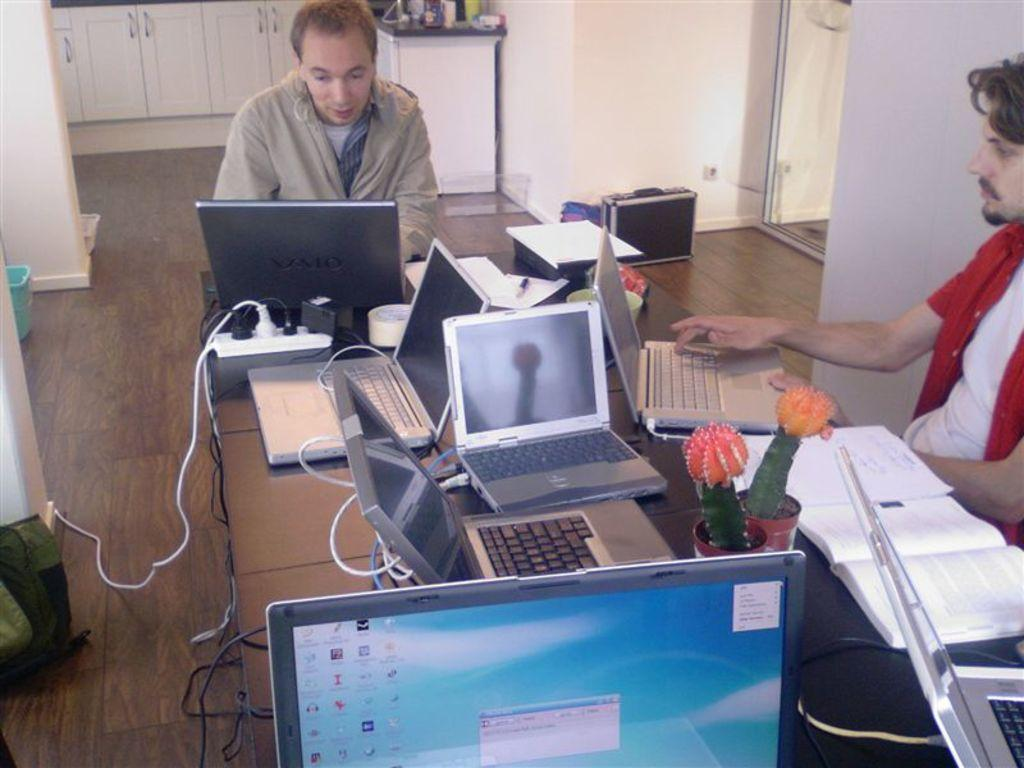<image>
Relay a brief, clear account of the picture shown. The computer at the front of the desk includes the Audacity music editing software. 